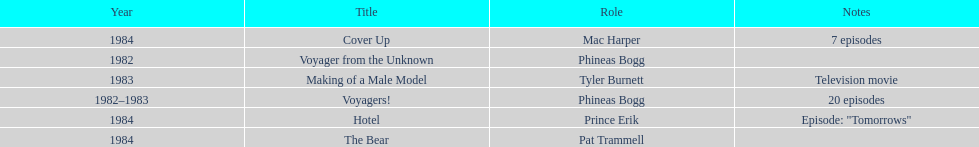Which year did he play the role of mac harper and also pat trammell? 1984. 